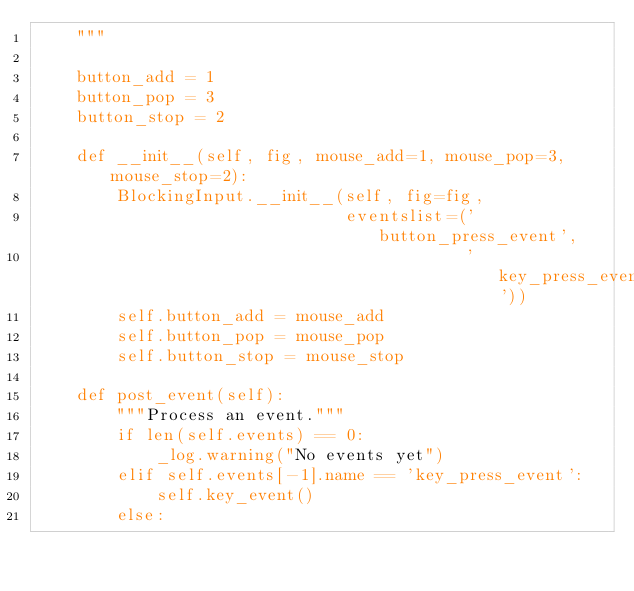<code> <loc_0><loc_0><loc_500><loc_500><_Python_>    """

    button_add = 1
    button_pop = 3
    button_stop = 2

    def __init__(self, fig, mouse_add=1, mouse_pop=3, mouse_stop=2):
        BlockingInput.__init__(self, fig=fig,
                               eventslist=('button_press_event',
                                           'key_press_event'))
        self.button_add = mouse_add
        self.button_pop = mouse_pop
        self.button_stop = mouse_stop

    def post_event(self):
        """Process an event."""
        if len(self.events) == 0:
            _log.warning("No events yet")
        elif self.events[-1].name == 'key_press_event':
            self.key_event()
        else:</code> 